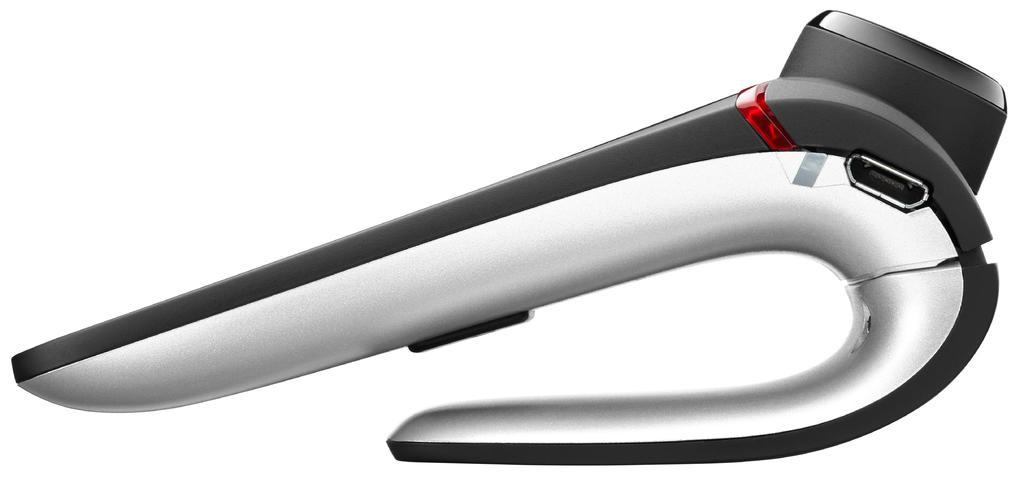What type of electronic device is in the center of the image? There is a bluetooth earphone in the center of the image. Can you describe the position of the bluetooth earphone in the image? The bluetooth earphone is in the center of the image. What type of drawer is visible in the image? There is no drawer present in the image; it only features a bluetooth earphone. 